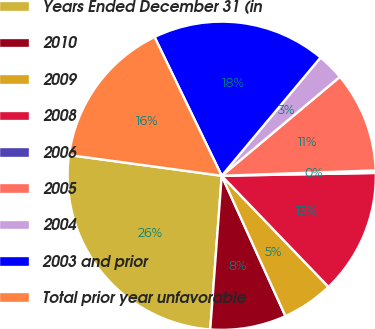<chart> <loc_0><loc_0><loc_500><loc_500><pie_chart><fcel>Years Ended December 31 (in<fcel>2010<fcel>2009<fcel>2008<fcel>2006<fcel>2005<fcel>2004<fcel>2003 and prior<fcel>Total prior year unfavorable<nl><fcel>25.96%<fcel>7.97%<fcel>5.4%<fcel>13.11%<fcel>0.26%<fcel>10.54%<fcel>2.83%<fcel>18.25%<fcel>15.68%<nl></chart> 